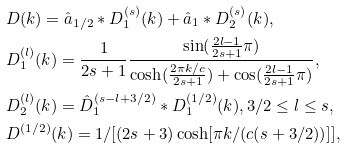<formula> <loc_0><loc_0><loc_500><loc_500>& { D } ( k ) = \hat { a } _ { 1 / 2 } * { D } ^ { ( s ) } _ { 1 } ( k ) + \hat { a } _ { 1 } * { D } ^ { ( s ) } _ { 2 } ( k ) , \\ & { D } ^ { ( l ) } _ { 1 } ( k ) = \frac { 1 } { 2 s + 1 } \frac { \sin ( \frac { 2 l - 1 } { 2 s + 1 } \pi ) } { \cosh ( \frac { 2 \pi k / c } { 2 s + 1 } ) + \cos ( \frac { 2 l - 1 } { 2 s + 1 } \pi ) } , \\ & { D } ^ { ( l ) } _ { 2 } ( k ) = \hat { D } ^ { ( s - l + 3 / 2 ) } _ { 1 } * { D } _ { 1 } ^ { ( 1 / 2 ) } ( k ) , { 3 } / 2 \leq l \leq s , \\ & { D } ^ { ( 1 / 2 ) } ( k ) = { 1 } / [ ( 2 s + 3 ) \cosh [ { \pi k } / { ( c ( s + 3 / 2 ) ) } ] ] ,</formula> 